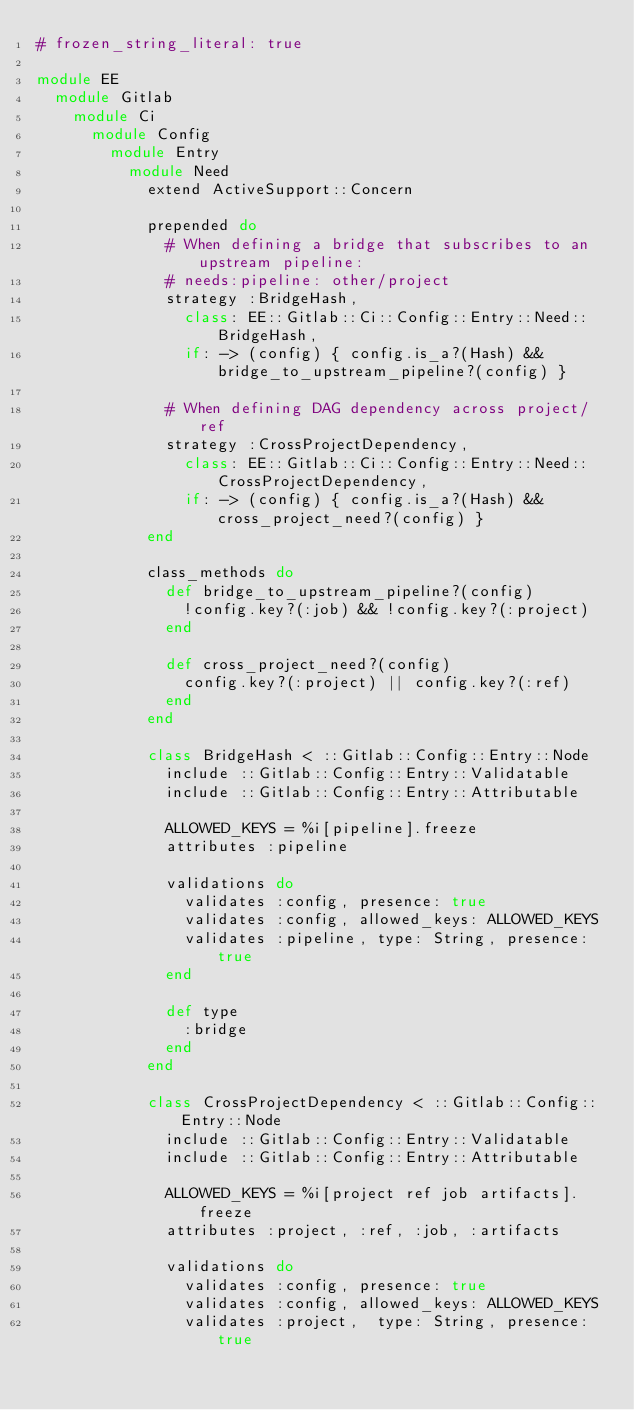<code> <loc_0><loc_0><loc_500><loc_500><_Ruby_># frozen_string_literal: true

module EE
  module Gitlab
    module Ci
      module Config
        module Entry
          module Need
            extend ActiveSupport::Concern

            prepended do
              # When defining a bridge that subscribes to an upstream pipeline:
              # needs:pipeline: other/project
              strategy :BridgeHash,
                class: EE::Gitlab::Ci::Config::Entry::Need::BridgeHash,
                if: -> (config) { config.is_a?(Hash) && bridge_to_upstream_pipeline?(config) }

              # When defining DAG dependency across project/ref
              strategy :CrossProjectDependency,
                class: EE::Gitlab::Ci::Config::Entry::Need::CrossProjectDependency,
                if: -> (config) { config.is_a?(Hash) && cross_project_need?(config) }
            end

            class_methods do
              def bridge_to_upstream_pipeline?(config)
                !config.key?(:job) && !config.key?(:project)
              end

              def cross_project_need?(config)
                config.key?(:project) || config.key?(:ref)
              end
            end

            class BridgeHash < ::Gitlab::Config::Entry::Node
              include ::Gitlab::Config::Entry::Validatable
              include ::Gitlab::Config::Entry::Attributable

              ALLOWED_KEYS = %i[pipeline].freeze
              attributes :pipeline

              validations do
                validates :config, presence: true
                validates :config, allowed_keys: ALLOWED_KEYS
                validates :pipeline, type: String, presence: true
              end

              def type
                :bridge
              end
            end

            class CrossProjectDependency < ::Gitlab::Config::Entry::Node
              include ::Gitlab::Config::Entry::Validatable
              include ::Gitlab::Config::Entry::Attributable

              ALLOWED_KEYS = %i[project ref job artifacts].freeze
              attributes :project, :ref, :job, :artifacts

              validations do
                validates :config, presence: true
                validates :config, allowed_keys: ALLOWED_KEYS
                validates :project,  type: String, presence: true</code> 